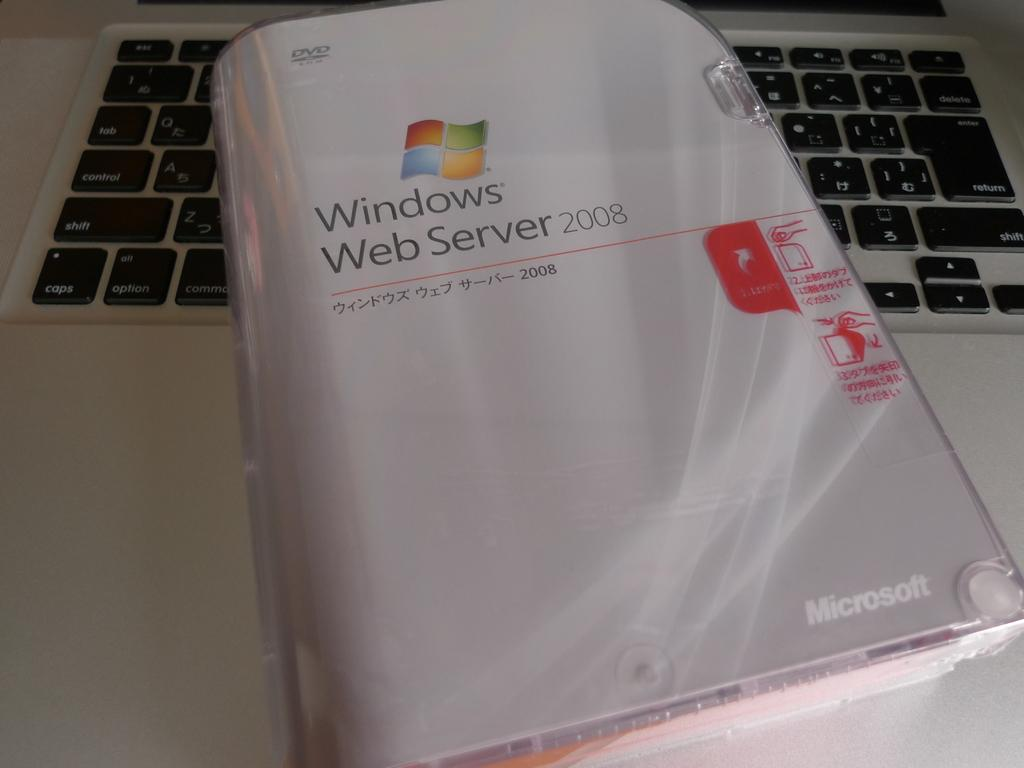<image>
Create a compact narrative representing the image presented. A package contains DVD's for the windows web server 2008. 